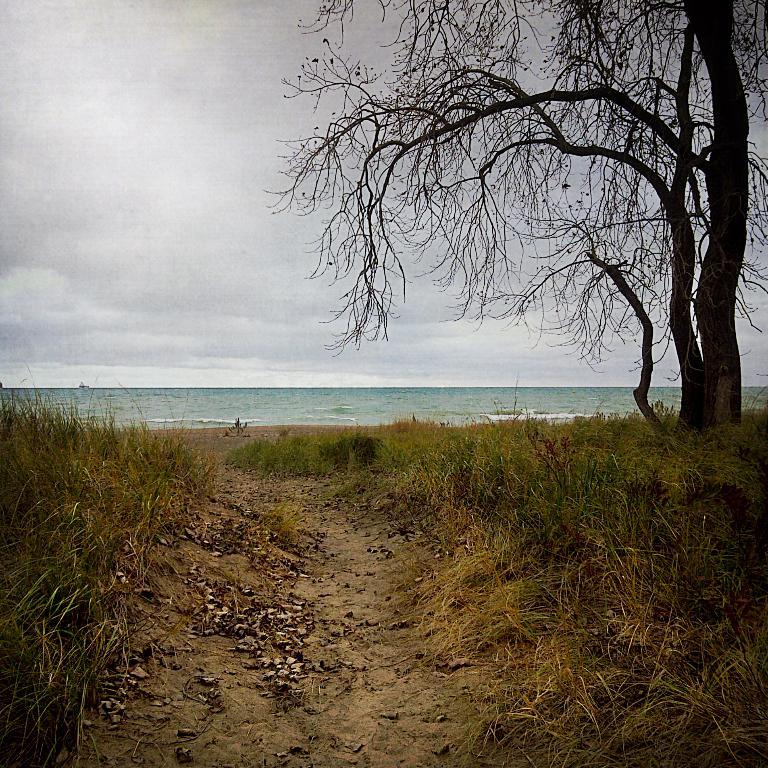What type of vegetation can be seen in the image? There is grass in the image. What else can be seen on the ground in the image? There are leaves on the path in the image. Where is the tree located in the image? The tree is on the right side of the image. What is visible in the background of the image? There is water visible in the background of the image. How would you describe the sky in the image? The sky is cloudy in the image. What type of honey is being reported on the news in the image? There is no news or honey present in the image; it features grass, leaves, a tree, water, and a cloudy sky. What type of playground equipment can be seen in the image? There is no playground equipment present in the image. 